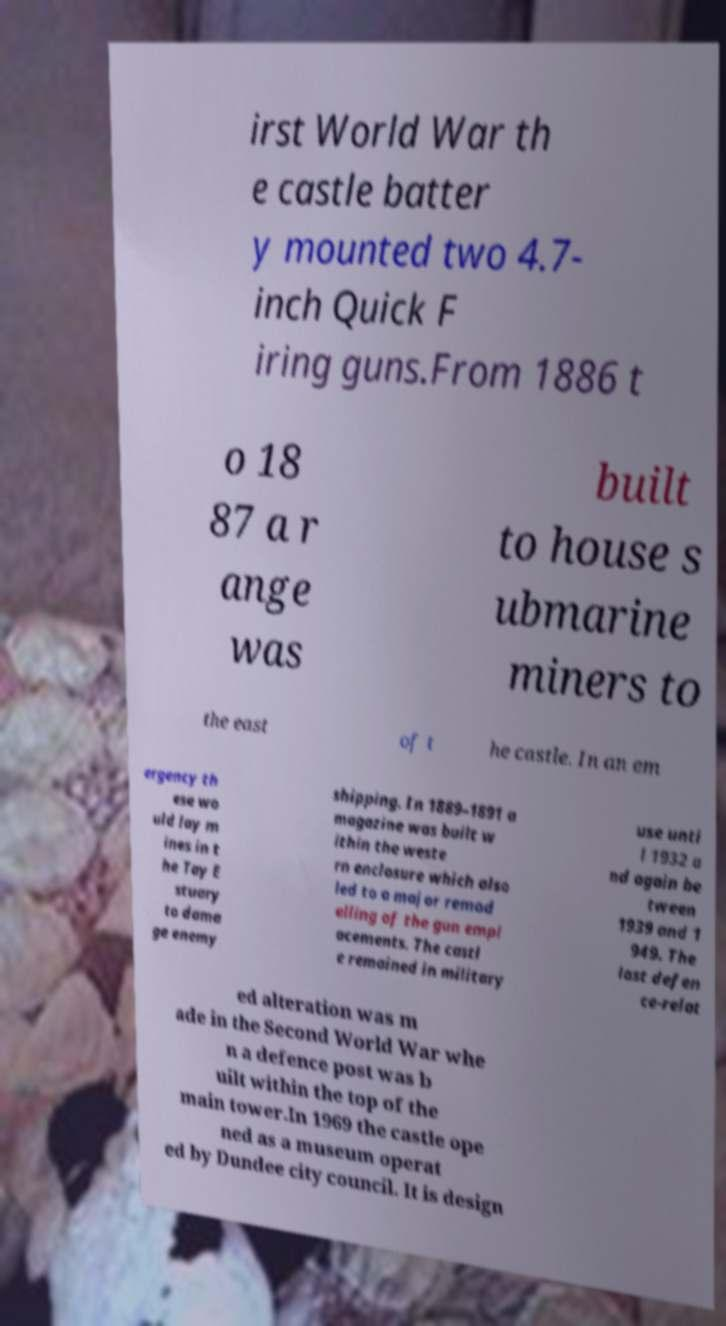Could you extract and type out the text from this image? irst World War th e castle batter y mounted two 4.7- inch Quick F iring guns.From 1886 t o 18 87 a r ange was built to house s ubmarine miners to the east of t he castle. In an em ergency th ese wo uld lay m ines in t he Tay E stuary to dama ge enemy shipping. In 1889–1891 a magazine was built w ithin the weste rn enclosure which also led to a major remod elling of the gun empl acements. The castl e remained in military use unti l 1932 a nd again be tween 1939 and 1 949. The last defen ce-relat ed alteration was m ade in the Second World War whe n a defence post was b uilt within the top of the main tower.In 1969 the castle ope ned as a museum operat ed by Dundee city council. It is design 